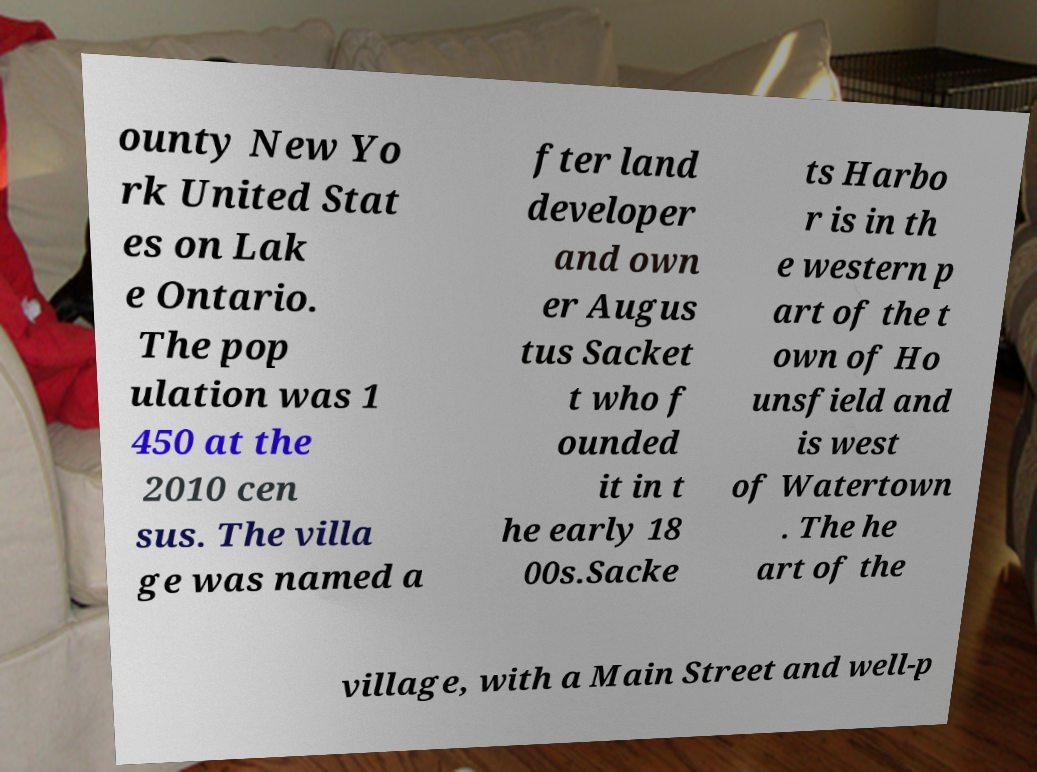For documentation purposes, I need the text within this image transcribed. Could you provide that? ounty New Yo rk United Stat es on Lak e Ontario. The pop ulation was 1 450 at the 2010 cen sus. The villa ge was named a fter land developer and own er Augus tus Sacket t who f ounded it in t he early 18 00s.Sacke ts Harbo r is in th e western p art of the t own of Ho unsfield and is west of Watertown . The he art of the village, with a Main Street and well-p 